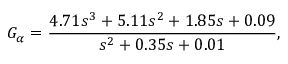Convert formula to latex. <formula><loc_0><loc_0><loc_500><loc_500>G _ { \alpha } = \frac { 4 . 7 1 s ^ { 3 } + 5 . 1 1 s ^ { 2 } + 1 . 8 5 s + 0 . 0 9 } { s ^ { 2 } + 0 . 3 5 s + 0 . 0 1 } ,</formula> 